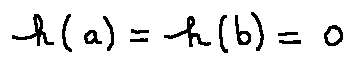<formula> <loc_0><loc_0><loc_500><loc_500>h ( a ) = h ( b ) = 0</formula> 